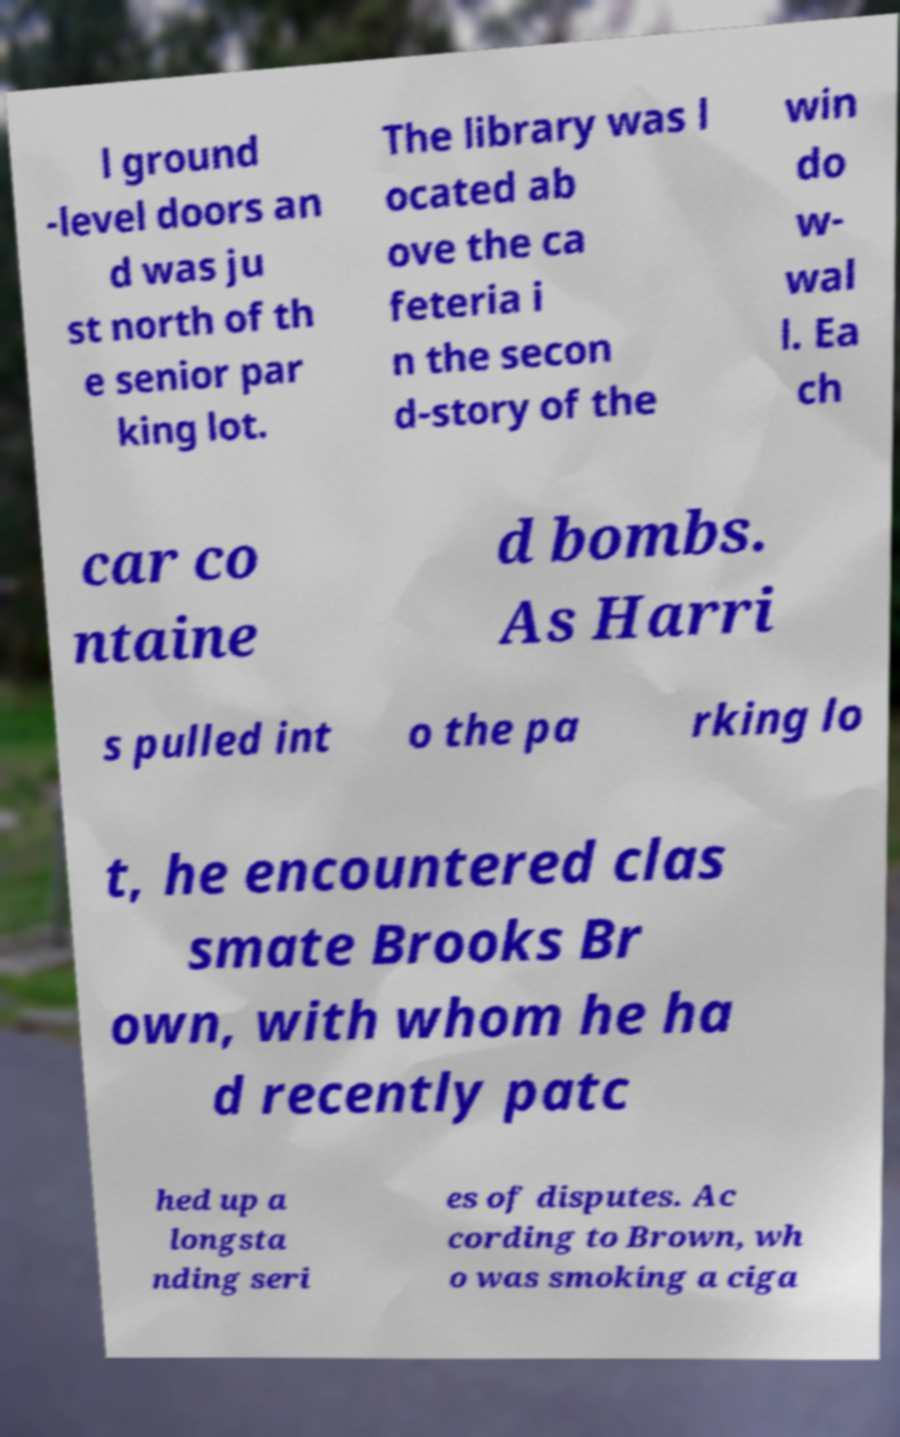Please read and relay the text visible in this image. What does it say? l ground -level doors an d was ju st north of th e senior par king lot. The library was l ocated ab ove the ca feteria i n the secon d-story of the win do w- wal l. Ea ch car co ntaine d bombs. As Harri s pulled int o the pa rking lo t, he encountered clas smate Brooks Br own, with whom he ha d recently patc hed up a longsta nding seri es of disputes. Ac cording to Brown, wh o was smoking a ciga 